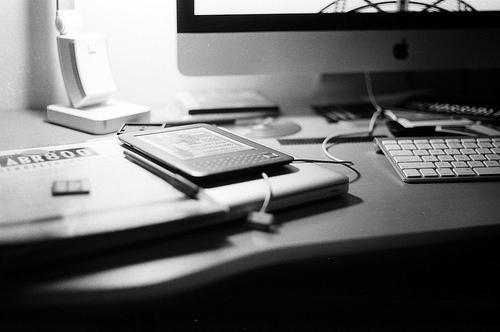How many phones are in the photo?
Give a very brief answer. 1. 